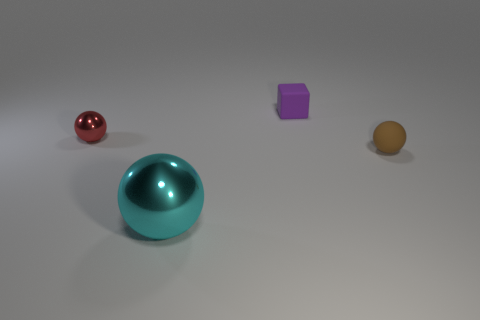Add 1 tiny rubber cubes. How many objects exist? 5 Subtract all blocks. How many objects are left? 3 Subtract all tiny brown metal things. Subtract all tiny brown rubber things. How many objects are left? 3 Add 3 large cyan balls. How many large cyan balls are left? 4 Add 2 tiny metallic things. How many tiny metallic things exist? 3 Subtract 0 purple balls. How many objects are left? 4 